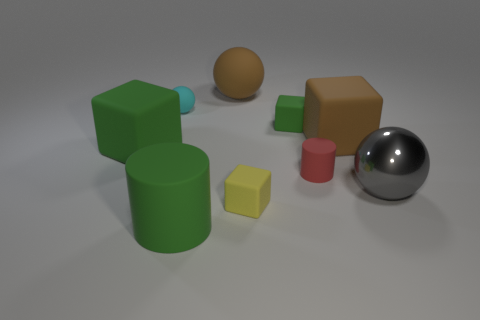Is there any other thing that is made of the same material as the gray thing?
Offer a very short reply. No. The thing that is the same color as the large matte sphere is what size?
Keep it short and to the point. Large. How many big rubber things are the same color as the big cylinder?
Your answer should be compact. 1. There is a thing that is both in front of the metal object and on the left side of the small yellow block; what color is it?
Offer a very short reply. Green. How many brown cubes are made of the same material as the tiny yellow thing?
Offer a very short reply. 1. How many large blocks are there?
Offer a terse response. 2. There is a red rubber thing; is its size the same as the green matte block that is left of the small yellow block?
Your answer should be compact. No. What is the material of the green object that is in front of the tiny object on the right side of the tiny green thing?
Your response must be concise. Rubber. What size is the green matte thing in front of the rubber cube that is on the left side of the brown thing that is left of the yellow cube?
Your answer should be compact. Large. Does the yellow matte object have the same shape as the thing that is on the left side of the cyan ball?
Keep it short and to the point. Yes. 